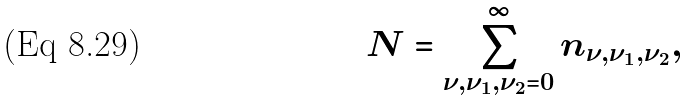<formula> <loc_0><loc_0><loc_500><loc_500>N = \sum _ { \nu , \nu _ { 1 } , \nu _ { 2 } = 0 } ^ { \infty } n _ { \nu , \nu _ { 1 } , \nu _ { 2 } } ,</formula> 